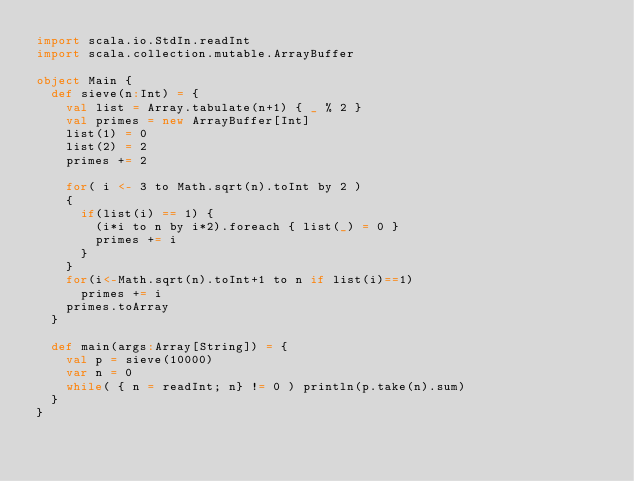Convert code to text. <code><loc_0><loc_0><loc_500><loc_500><_Scala_>import scala.io.StdIn.readInt
import scala.collection.mutable.ArrayBuffer

object Main {
  def sieve(n:Int) = {
    val list = Array.tabulate(n+1) { _ % 2 }
    val primes = new ArrayBuffer[Int]
    list(1) = 0
    list(2) = 2
    primes += 2

    for( i <- 3 to Math.sqrt(n).toInt by 2 )
    {
      if(list(i) == 1) {
        (i*i to n by i*2).foreach { list(_) = 0 }
        primes += i
      }
    }
    for(i<-Math.sqrt(n).toInt+1 to n if list(i)==1)
      primes += i
    primes.toArray
  }

  def main(args:Array[String]) = {
    val p = sieve(10000)
    var n = 0
    while( { n = readInt; n} != 0 ) println(p.take(n).sum)
  }
}</code> 